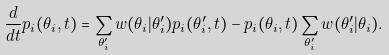<formula> <loc_0><loc_0><loc_500><loc_500>\frac { d } { d t } p _ { i } ( \theta _ { i } , t ) = \sum _ { \theta _ { i } ^ { \prime } } w ( \theta _ { i } | \theta _ { i } ^ { \prime } ) p _ { i } ( \theta _ { i } ^ { \prime } , t ) - p _ { i } ( \theta _ { i } , t ) \sum _ { \theta _ { i } ^ { \prime } } w ( \theta _ { i } ^ { \prime } | \theta _ { i } ) .</formula> 